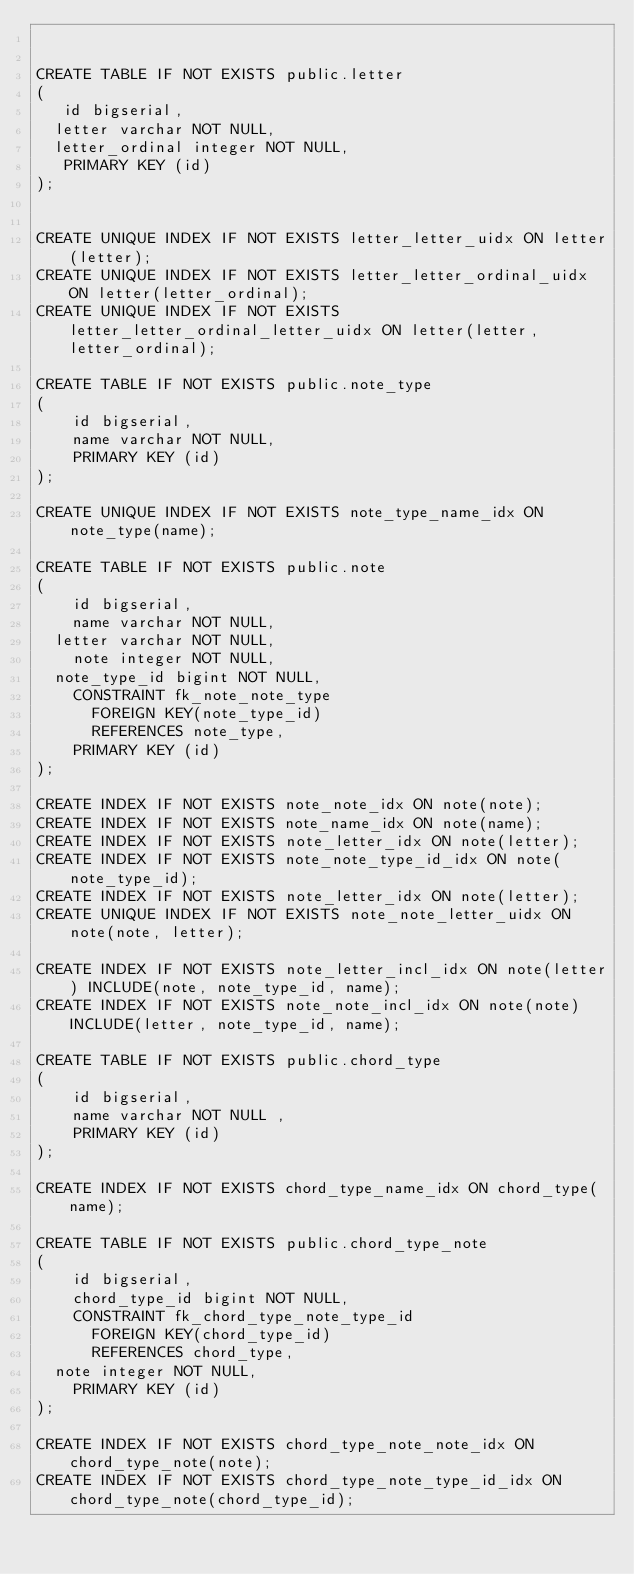<code> <loc_0><loc_0><loc_500><loc_500><_SQL_>

CREATE TABLE IF NOT EXISTS public.letter
(
   id bigserial,
	letter varchar NOT NULL,
	letter_ordinal integer NOT NULL,
   PRIMARY KEY (id)
);


CREATE UNIQUE INDEX IF NOT EXISTS letter_letter_uidx ON letter(letter);
CREATE UNIQUE INDEX IF NOT EXISTS letter_letter_ordinal_uidx ON letter(letter_ordinal);
CREATE UNIQUE INDEX IF NOT EXISTS letter_letter_ordinal_letter_uidx ON letter(letter, letter_ordinal);

CREATE TABLE IF NOT EXISTS public.note_type
(
    id bigserial,
    name varchar NOT NULL,
    PRIMARY KEY (id)
);

CREATE UNIQUE INDEX IF NOT EXISTS note_type_name_idx ON note_type(name);

CREATE TABLE IF NOT EXISTS public.note
(
    id bigserial,
    name varchar NOT NULL,
	letter varchar NOT NULL,
    note integer NOT NULL,
	note_type_id bigint NOT NULL,
		CONSTRAINT fk_note_note_type
			FOREIGN KEY(note_type_id)
			REFERENCES note_type,
    PRIMARY KEY (id)
);

CREATE INDEX IF NOT EXISTS note_note_idx ON note(note);
CREATE INDEX IF NOT EXISTS note_name_idx ON note(name);
CREATE INDEX IF NOT EXISTS note_letter_idx ON note(letter);
CREATE INDEX IF NOT EXISTS note_note_type_id_idx ON note(note_type_id);
CREATE INDEX IF NOT EXISTS note_letter_idx ON note(letter);
CREATE UNIQUE INDEX IF NOT EXISTS note_note_letter_uidx ON note(note, letter);

CREATE INDEX IF NOT EXISTS note_letter_incl_idx ON note(letter) INCLUDE(note, note_type_id, name);
CREATE INDEX IF NOT EXISTS note_note_incl_idx ON note(note) INCLUDE(letter, note_type_id, name);

CREATE TABLE IF NOT EXISTS public.chord_type
(
    id bigserial,
    name varchar NOT NULL ,
    PRIMARY KEY (id)
);

CREATE INDEX IF NOT EXISTS chord_type_name_idx ON chord_type(name);

CREATE TABLE IF NOT EXISTS public.chord_type_note
(
    id bigserial,
    chord_type_id bigint NOT NULL,
		CONSTRAINT fk_chord_type_note_type_id
			FOREIGN KEY(chord_type_id)
			REFERENCES chord_type,
	note integer NOT NULL,
    PRIMARY KEY (id)
);

CREATE INDEX IF NOT EXISTS chord_type_note_note_idx ON chord_type_note(note);
CREATE INDEX IF NOT EXISTS chord_type_note_type_id_idx ON chord_type_note(chord_type_id);</code> 